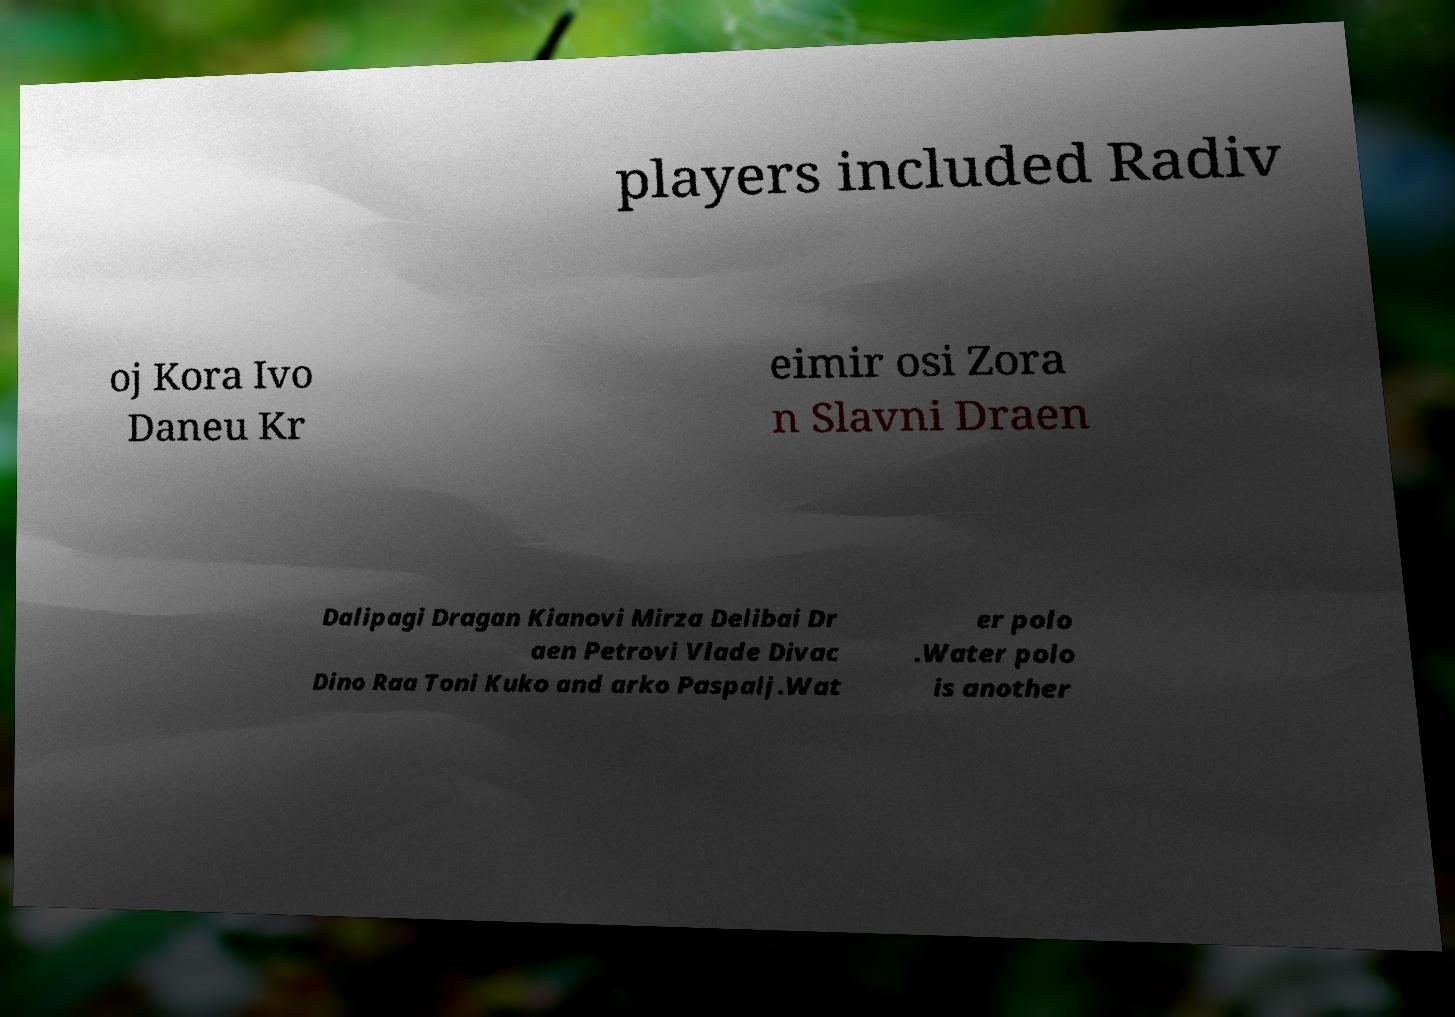Can you read and provide the text displayed in the image?This photo seems to have some interesting text. Can you extract and type it out for me? players included Radiv oj Kora Ivo Daneu Kr eimir osi Zora n Slavni Draen Dalipagi Dragan Kianovi Mirza Delibai Dr aen Petrovi Vlade Divac Dino Raa Toni Kuko and arko Paspalj.Wat er polo .Water polo is another 